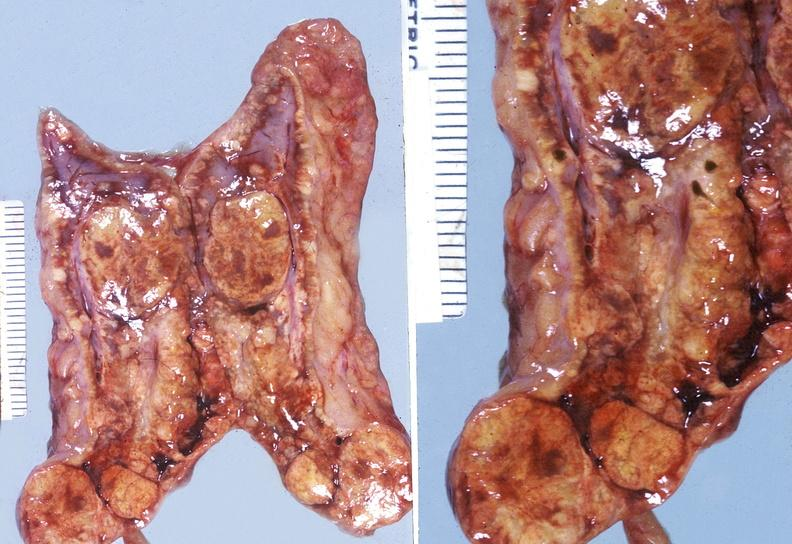where does this belong to?
Answer the question using a single word or phrase. Endocrine system 